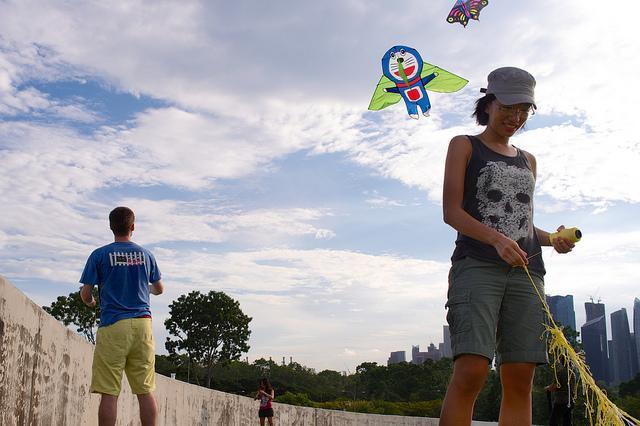How many people are there?
Give a very brief answer. 2. 